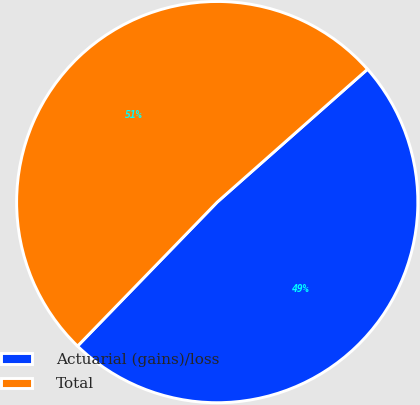Convert chart. <chart><loc_0><loc_0><loc_500><loc_500><pie_chart><fcel>Actuarial (gains)/loss<fcel>Total<nl><fcel>48.78%<fcel>51.22%<nl></chart> 